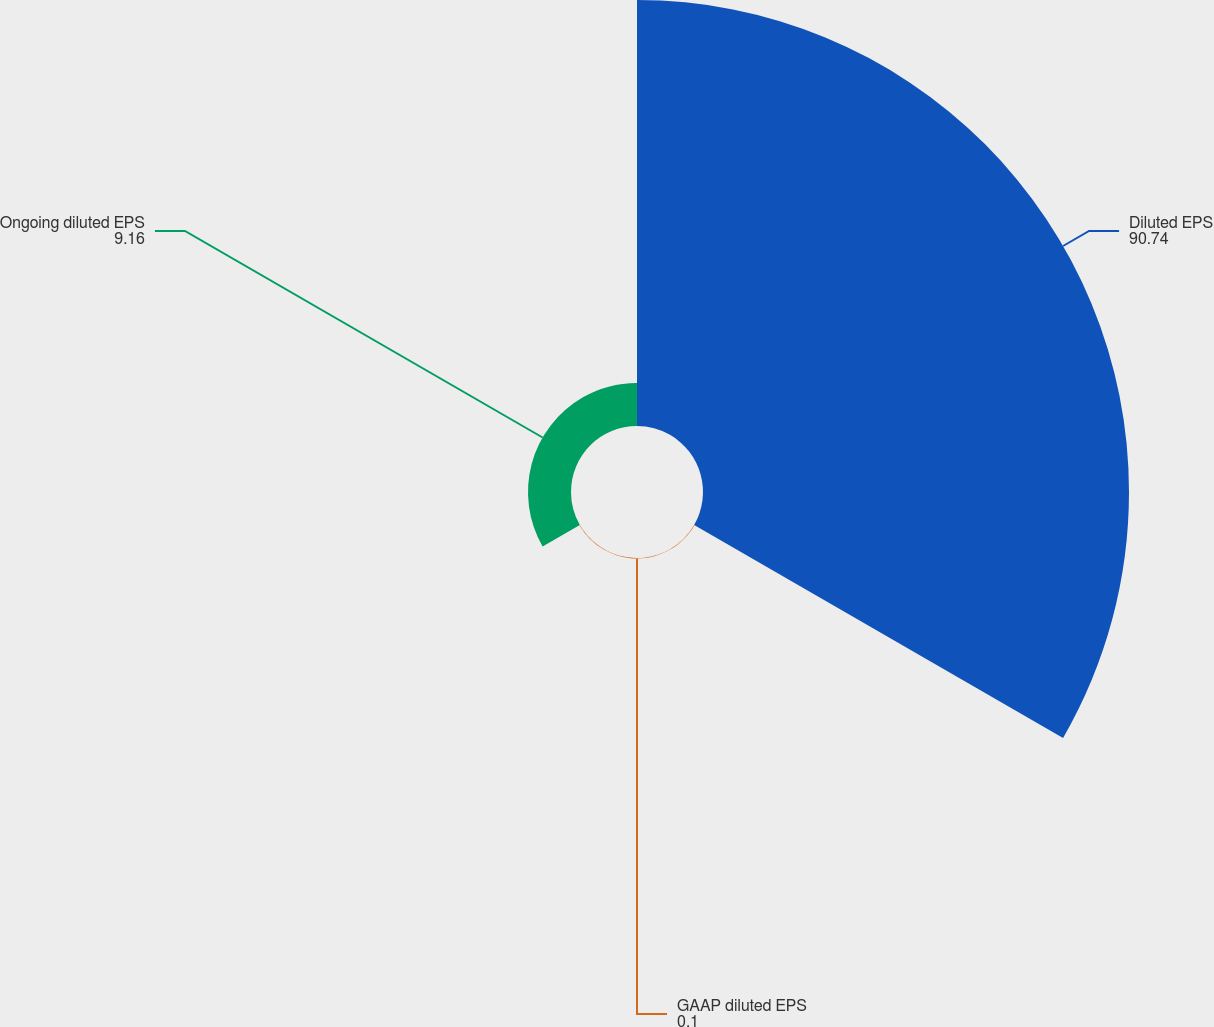Convert chart. <chart><loc_0><loc_0><loc_500><loc_500><pie_chart><fcel>Diluted EPS<fcel>GAAP diluted EPS<fcel>Ongoing diluted EPS<nl><fcel>90.74%<fcel>0.1%<fcel>9.16%<nl></chart> 